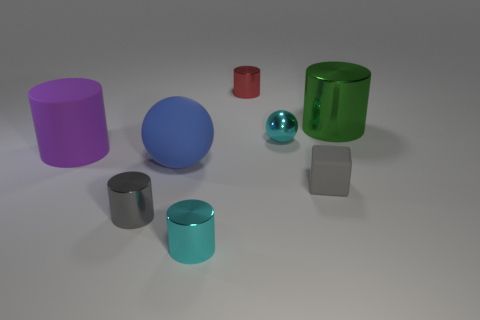Are there any large purple things that have the same shape as the small red metallic thing?
Provide a short and direct response. Yes. There is a small object that is to the right of the tiny red shiny object and behind the rubber ball; what is its shape?
Ensure brevity in your answer.  Sphere. What number of big red objects are the same material as the tiny cyan sphere?
Your answer should be very brief. 0. Are there fewer tiny red cylinders that are left of the tiny cyan cylinder than small red objects?
Your answer should be very brief. Yes. Are there any gray cylinders right of the small cyan metallic thing that is behind the purple object?
Give a very brief answer. No. Are there any other things that have the same shape as the tiny gray metallic thing?
Your response must be concise. Yes. Do the matte cube and the gray cylinder have the same size?
Keep it short and to the point. Yes. What is the material of the small cyan object that is in front of the gray metal cylinder that is behind the cyan metal thing that is in front of the big purple matte cylinder?
Your response must be concise. Metal. Is the number of small shiny objects behind the large green thing the same as the number of tiny yellow balls?
Give a very brief answer. No. Is there any other thing that is the same size as the blue ball?
Ensure brevity in your answer.  Yes. 